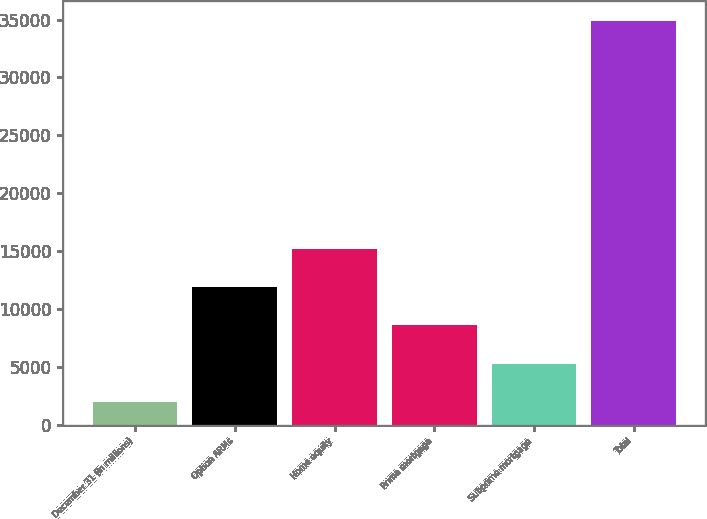<chart> <loc_0><loc_0><loc_500><loc_500><bar_chart><fcel>December 31 (in millions)<fcel>Option ARMs<fcel>Home equity<fcel>Prime mortgage<fcel>Subprime mortgage<fcel>Total<nl><fcel>2010<fcel>11873.4<fcel>15161.2<fcel>8585.6<fcel>5297.8<fcel>34888<nl></chart> 